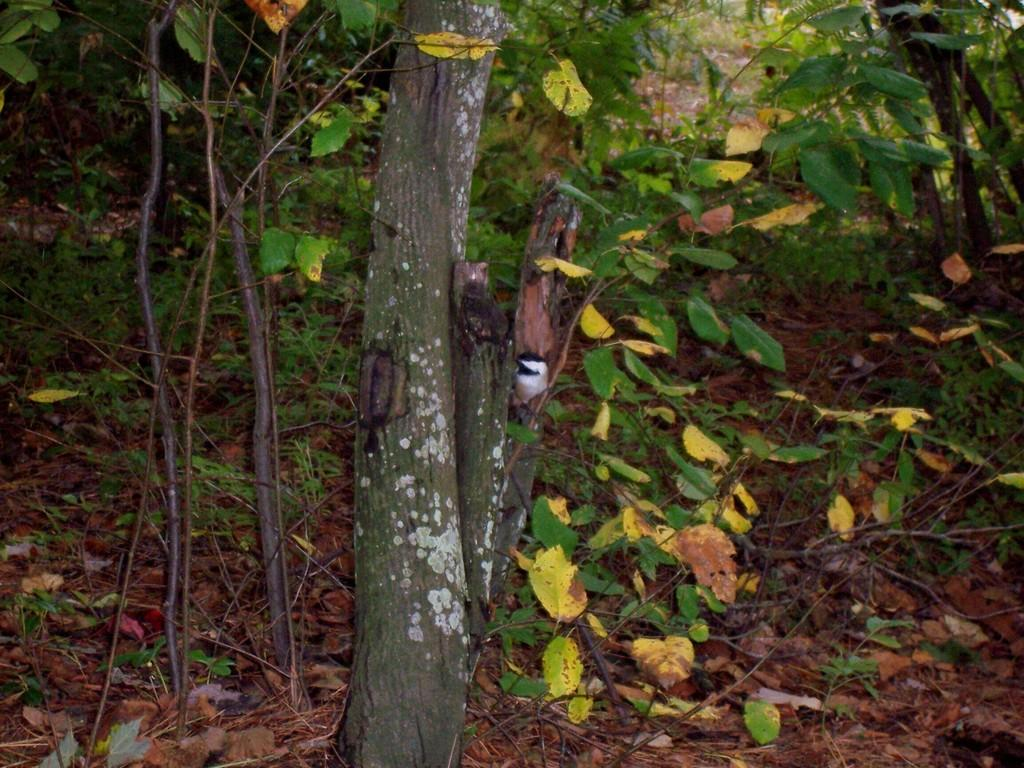What type of vegetation can be seen in the image? There are plants in the image. What part of a tree can be seen in the image? There is a tree trunk in the image. What else can be found on the ground in the image? Leaves are present on the ground in the image. How many geese are visible in the image? There are no geese present in the image. What type of door can be seen in the image? There is no door present in the image. 